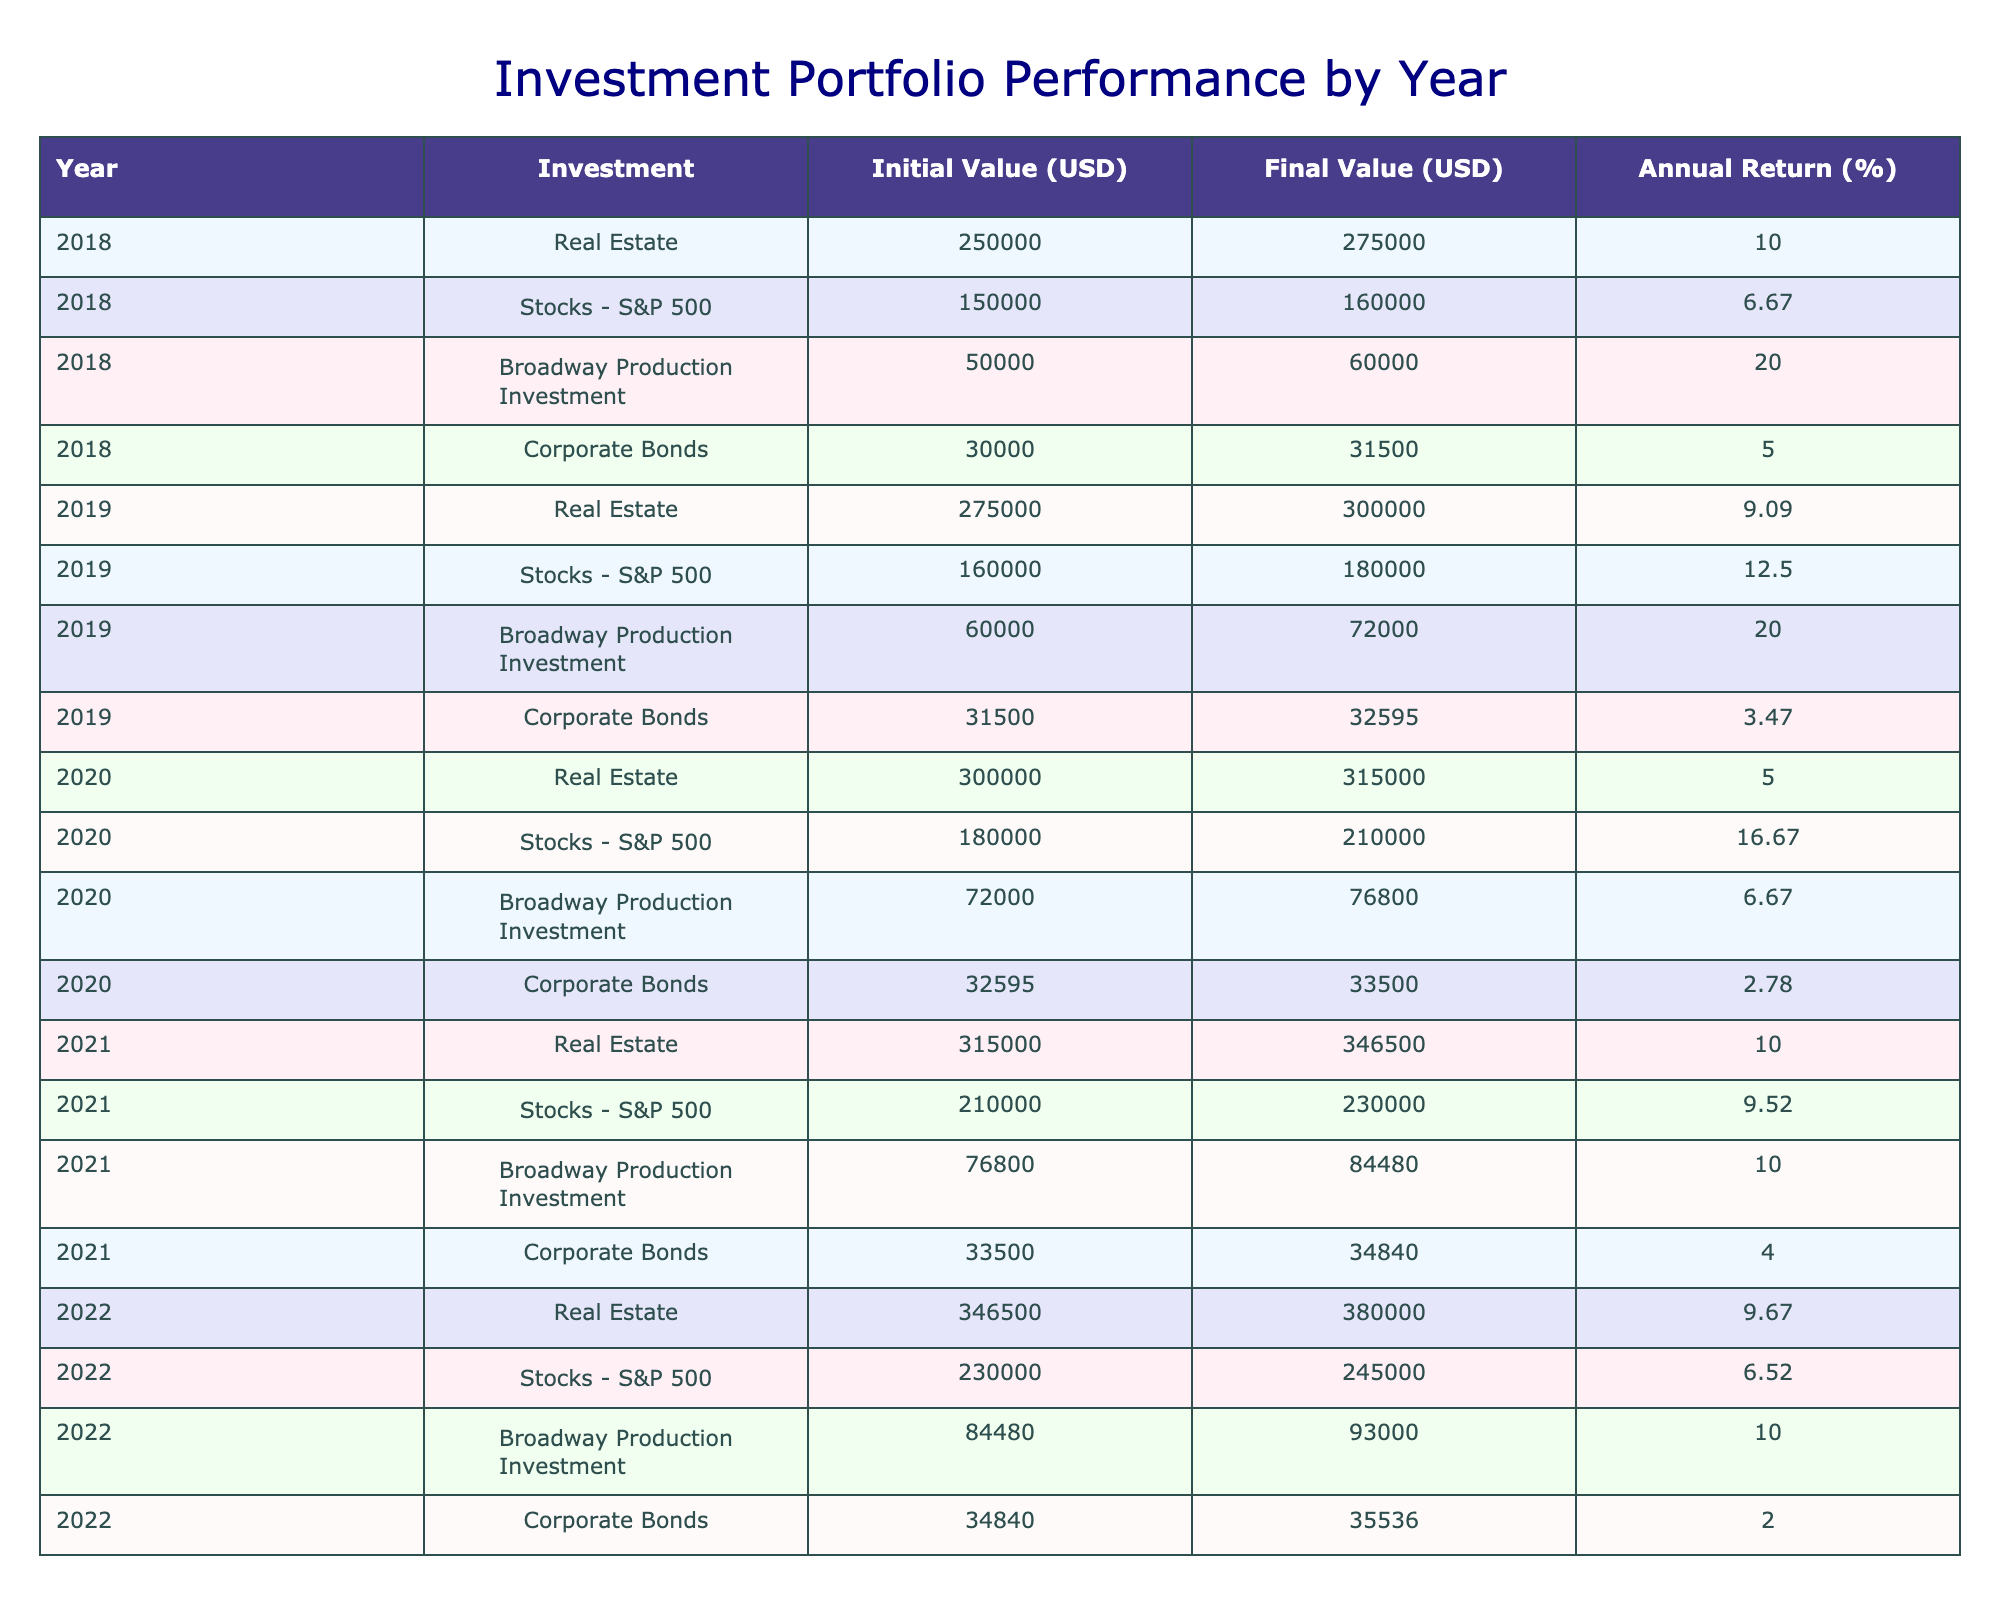What was the final value of the Broadway Production Investment in 2019? In 2019, the Broadway Production Investment had a final value listed in the table, which is 72000 USD.
Answer: 72000 What was the annual return on Corporate Bonds in 2020? The annual return for Corporate Bonds in 2020 is listed in the table as 2.78%.
Answer: 2.78% Which investment had the highest final value in 2021? To find the investment with the highest final value in 2021, we compare the final values of each investment: Real Estate is 346500 USD, Stocks - S&P 500 is 230000 USD, Broadway Production Investment is 84480 USD, and Corporate Bonds is 34840 USD. Real Estate has the highest final value.
Answer: Real Estate What was the average annual return for Real Estate over the years listed? To compute the average annual return for Real Estate, we sum the annual returns across the years: (10.0% + 9.09% + 5.0% + 10.0% + 9.67%) = 43.76%. Dividing by the number of years (5), we get an average of 43.76/5 = 8.752%.
Answer: 8.75 Did the Broadway Production Investment always have a return greater than 10%? Looking at the annual returns for Broadway Production Investment: 20.0% in 2018, 20.0% in 2019, 6.67% in 2020, 10.0% in 2021, and 10.0% in 2022. Therefore, there are years (2020) where the return was less than 10%.
Answer: No What is the difference in final value for Stocks - S&P 500 from 2018 to 2020? To find the difference in final value for Stocks - S&P 500, we subtract the final value in 2018 from that in 2020: 210000 USD (in 2020) - 160000 USD (in 2018) = 50000 USD.
Answer: 50000 In which year did Corporate Bonds achieve the highest final value? By reviewing the final values for Corporate Bonds over the years: 31500 USD in 2018, 32595 USD in 2019, 33500 USD in 2020, 34840 USD in 2021, and 35536 USD in 2022, we find that they reached the highest value of 35536 USD in 2022.
Answer: 2022 What was the total initial value of all investments in 2019? To calculate the total initial value of all investments in 2019, we add the initial values: 275000 (Real Estate) + 160000 (Stocks - S&P 500) + 60000 (Broadway Production Investment) + 31500 (Corporate Bonds) = 521500 USD.
Answer: 521500 Was the average annual return for Broadway Production Investment greater than for Corporate Bonds? The annual returns for Broadway Production Investment are 20.0%, 20.0%, 6.67%, 10.0%, and 10.0%, which averages to 13.73%. The annual returns for Corporate Bonds are 5.0%, 3.47%, 2.78%, 4.0%, and 2.0%, which averages to 3.83%. Since 13.73% is greater than 3.83%, the statement is true.
Answer: Yes 